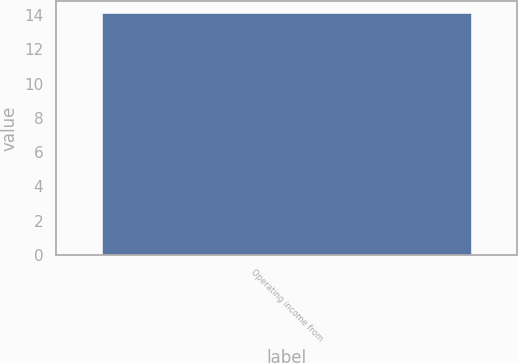<chart> <loc_0><loc_0><loc_500><loc_500><bar_chart><fcel>Operating income from<nl><fcel>14.1<nl></chart> 